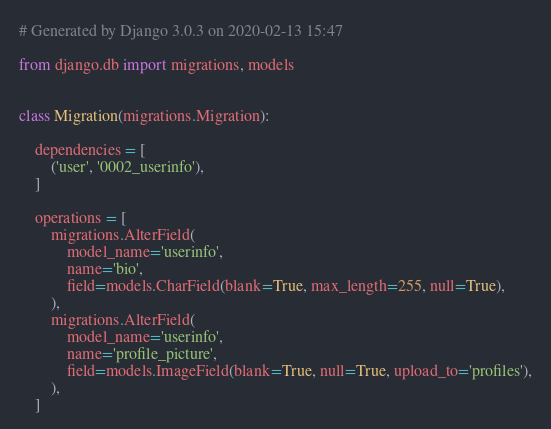Convert code to text. <code><loc_0><loc_0><loc_500><loc_500><_Python_># Generated by Django 3.0.3 on 2020-02-13 15:47

from django.db import migrations, models


class Migration(migrations.Migration):

    dependencies = [
        ('user', '0002_userinfo'),
    ]

    operations = [
        migrations.AlterField(
            model_name='userinfo',
            name='bio',
            field=models.CharField(blank=True, max_length=255, null=True),
        ),
        migrations.AlterField(
            model_name='userinfo',
            name='profile_picture',
            field=models.ImageField(blank=True, null=True, upload_to='profiles'),
        ),
    ]
</code> 